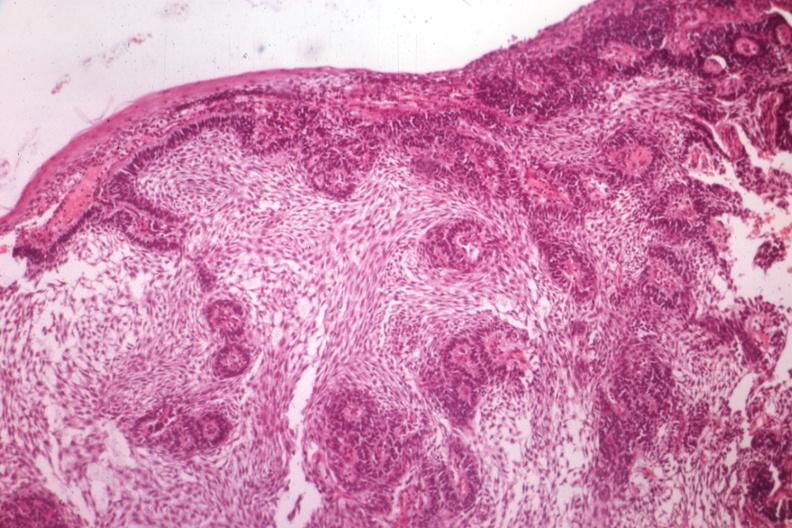s the unknown origin in mandible a guess?
Answer the question using a single word or phrase. Yes 